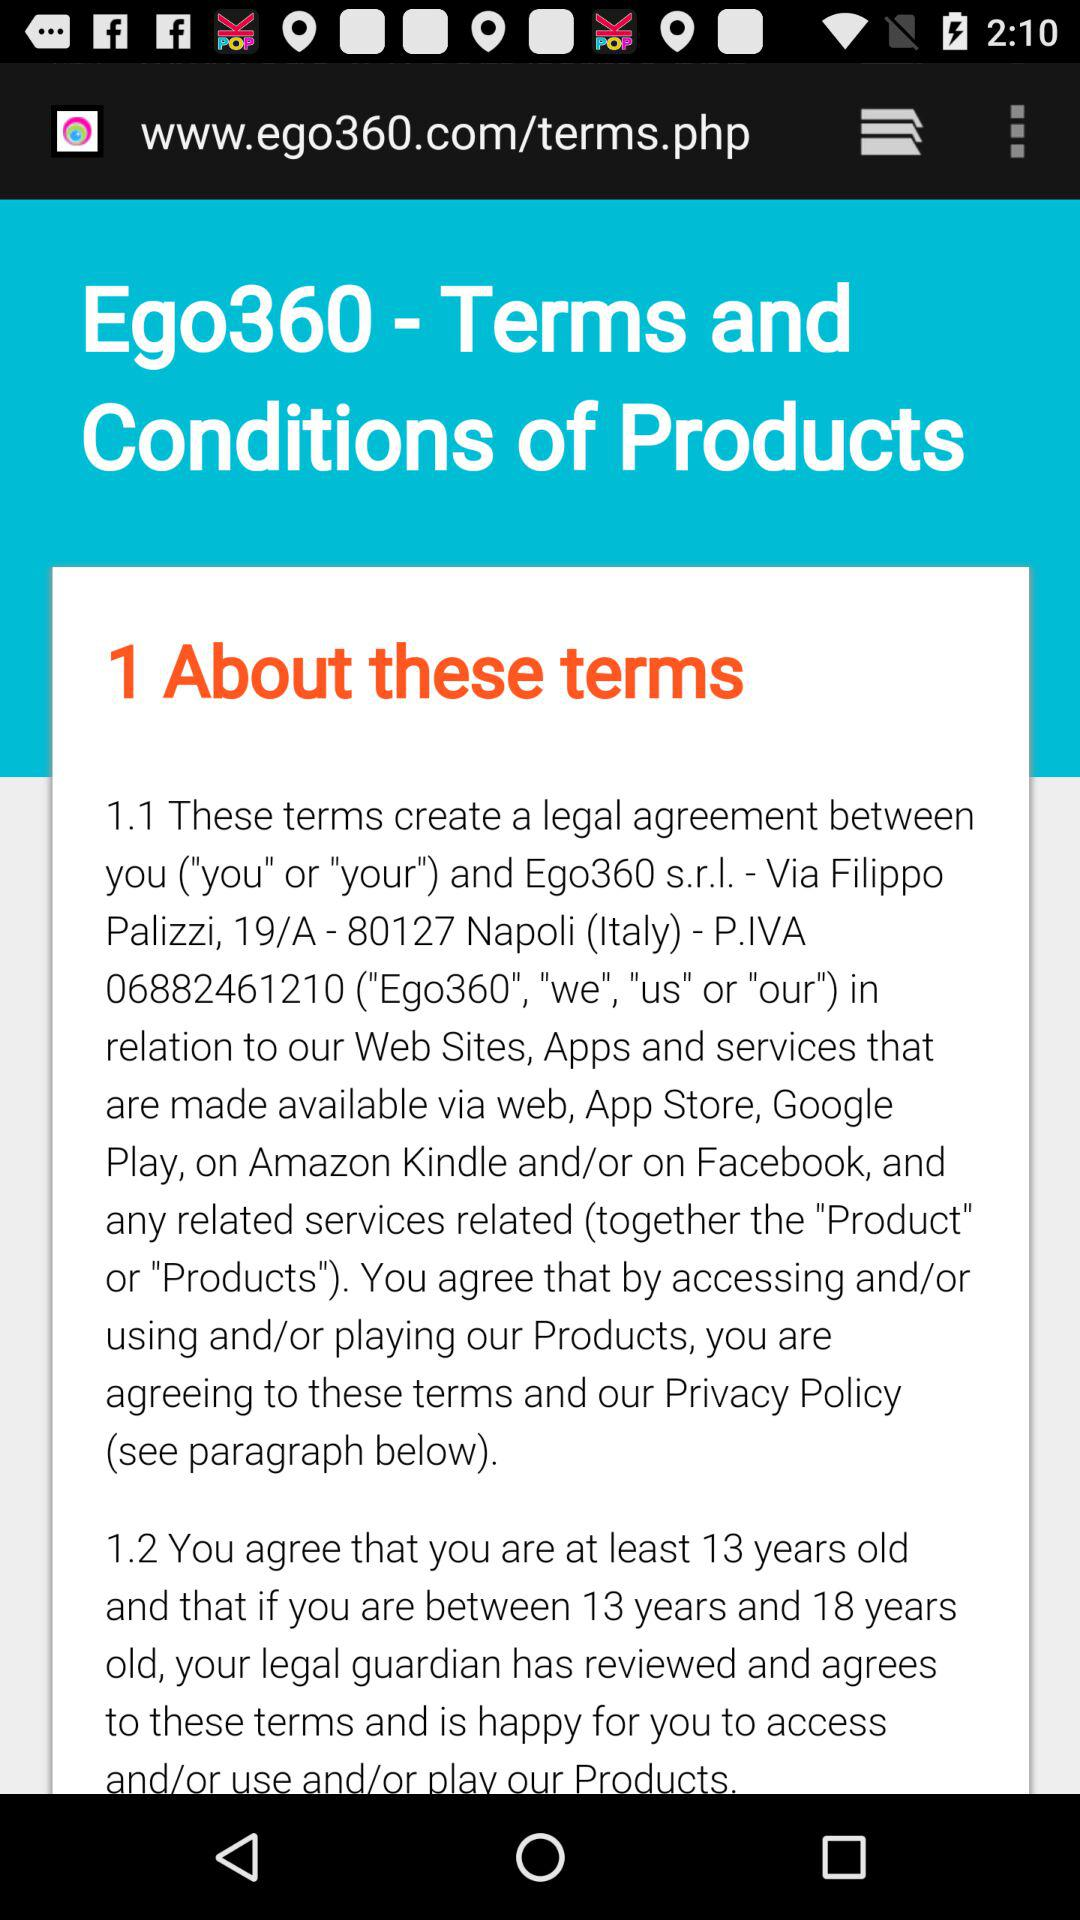How many legal entities are mentioned in the terms and conditions?
Answer the question using a single word or phrase. 2 